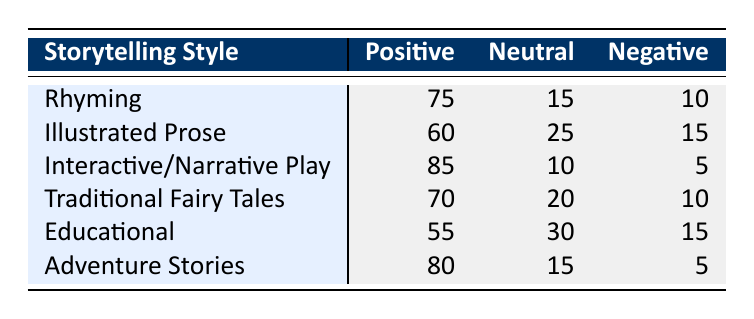What is the positive feedback percentage for Interactive/Narrative Play? The table shows that the positive feedback for Interactive/Narrative Play is 85.
Answer: 85 Which storytelling style received the least positive feedback? The table indicates that the educational storytelling style has 55 positive feedback, which is the lowest among all styles listed.
Answer: Educational What is the total amount of neutral feedback for Rhyming and Traditional Fairy Tales? The neutral feedback for Rhyming is 15 and for Traditional Fairy Tales is 20. Thus, the total is 15 + 20 = 35.
Answer: 35 Is it true that Adventure Stories have a lower negative feedback compared to Illustrated Prose? The negative feedback for Adventure Stories is 5, while for Illustrated Prose it is 15. Since 5 is less than 15, the statement is true.
Answer: Yes What is the average positive feedback across all storytelling styles listed? To find the average, sum the positive feedback values: 75 + 60 + 85 + 70 + 55 + 80 = 425. There are 6 styles, so the average is 425 / 6 = 70.83.
Answer: 70.83 